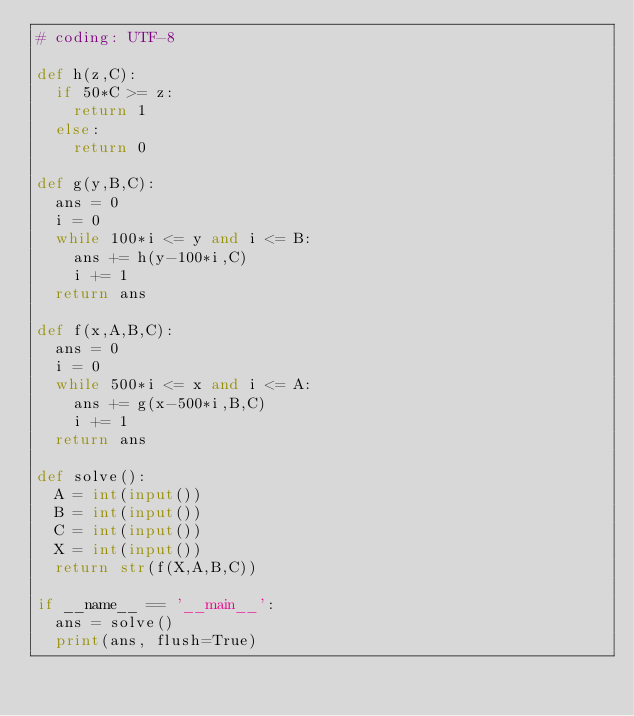Convert code to text. <code><loc_0><loc_0><loc_500><loc_500><_Python_># coding: UTF-8

def h(z,C):
  if 50*C >= z:
    return 1
  else:
    return 0

def g(y,B,C):
  ans = 0
  i = 0
  while 100*i <= y and i <= B:
    ans += h(y-100*i,C)
    i += 1
  return ans

def f(x,A,B,C):
  ans = 0
  i = 0
  while 500*i <= x and i <= A:
    ans += g(x-500*i,B,C)
    i += 1
  return ans

def solve():
  A = int(input())
  B = int(input())
  C = int(input())
  X = int(input())
  return str(f(X,A,B,C))
 
if __name__ == '__main__':
  ans = solve()
  print(ans, flush=True)</code> 